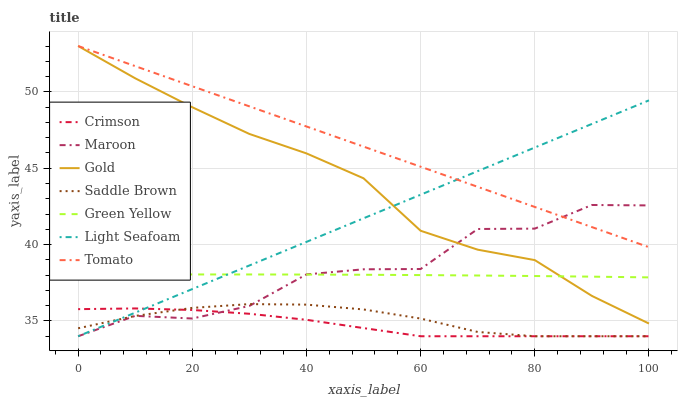Does Light Seafoam have the minimum area under the curve?
Answer yes or no. No. Does Light Seafoam have the maximum area under the curve?
Answer yes or no. No. Is Gold the smoothest?
Answer yes or no. No. Is Gold the roughest?
Answer yes or no. No. Does Gold have the lowest value?
Answer yes or no. No. Does Light Seafoam have the highest value?
Answer yes or no. No. Is Crimson less than Gold?
Answer yes or no. Yes. Is Green Yellow greater than Crimson?
Answer yes or no. Yes. Does Crimson intersect Gold?
Answer yes or no. No. 